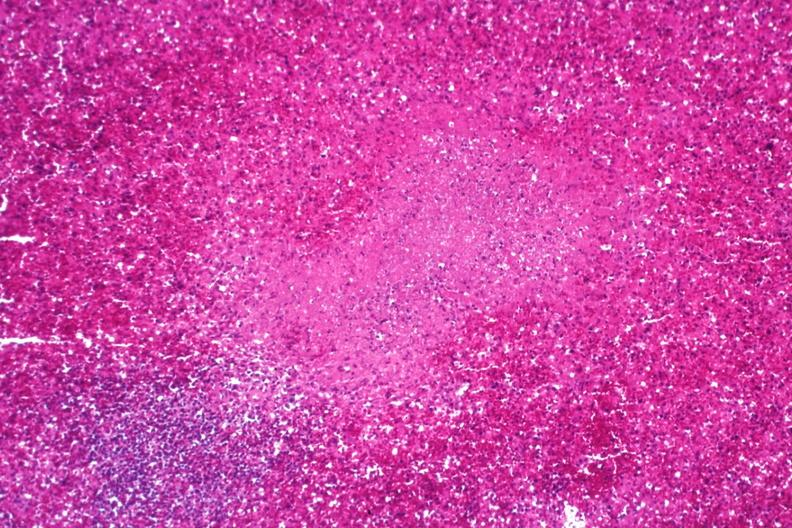what is present?
Answer the question using a single word or phrase. Miliary tuberculosis 